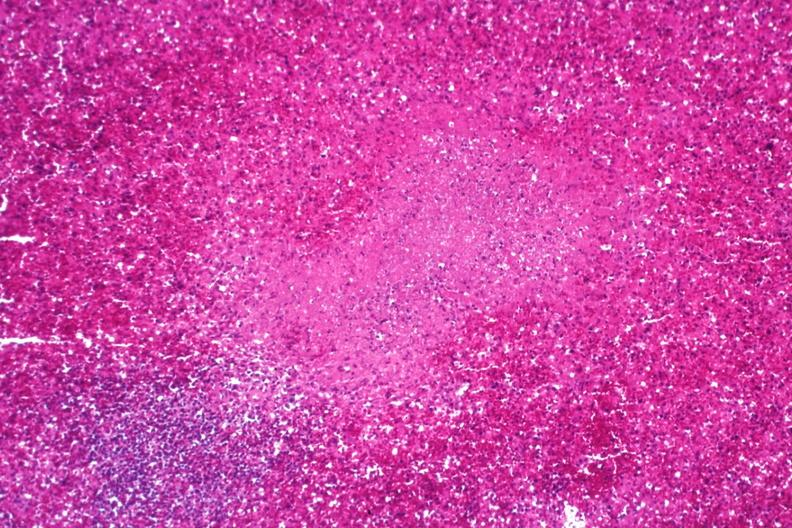what is present?
Answer the question using a single word or phrase. Miliary tuberculosis 